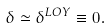<formula> <loc_0><loc_0><loc_500><loc_500>\delta \simeq { \delta } ^ { L O Y } \equiv 0 .</formula> 